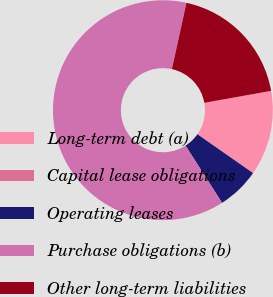Convert chart. <chart><loc_0><loc_0><loc_500><loc_500><pie_chart><fcel>Long-term debt (a)<fcel>Capital lease obligations<fcel>Operating leases<fcel>Purchase obligations (b)<fcel>Other long-term liabilities<nl><fcel>12.5%<fcel>0.01%<fcel>6.26%<fcel>62.48%<fcel>18.75%<nl></chart> 